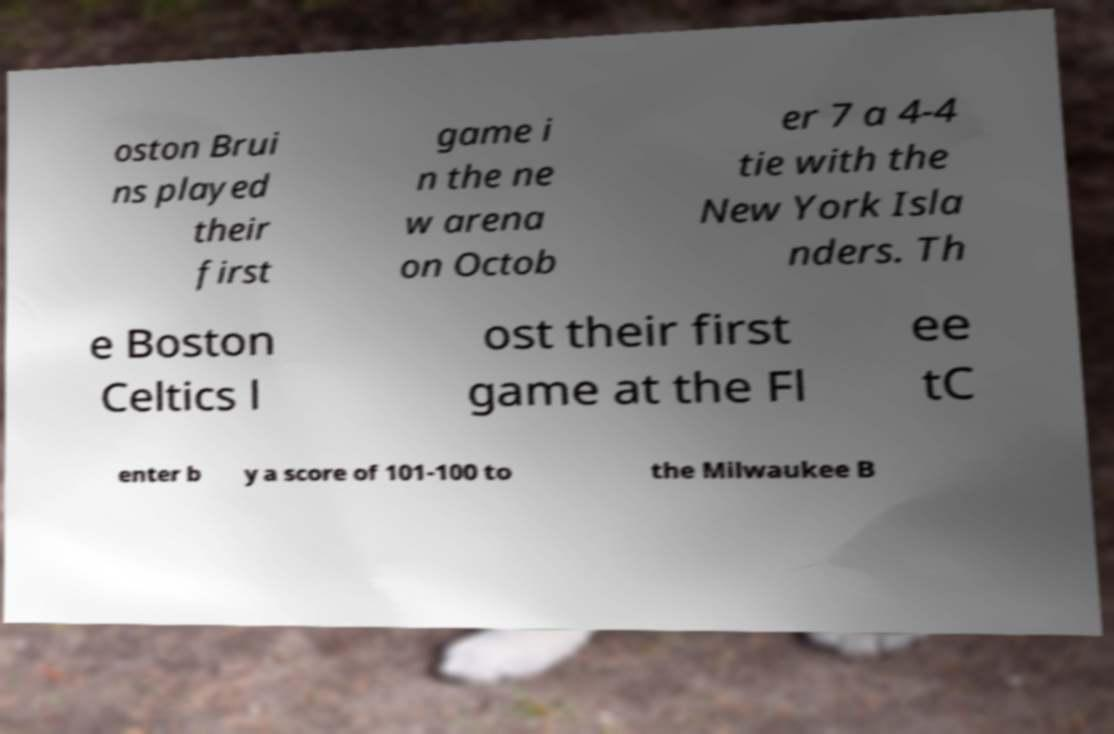I need the written content from this picture converted into text. Can you do that? oston Brui ns played their first game i n the ne w arena on Octob er 7 a 4-4 tie with the New York Isla nders. Th e Boston Celtics l ost their first game at the Fl ee tC enter b y a score of 101-100 to the Milwaukee B 